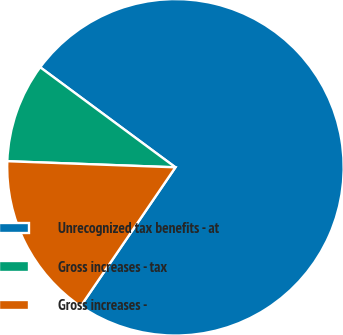Convert chart to OTSL. <chart><loc_0><loc_0><loc_500><loc_500><pie_chart><fcel>Unrecognized tax benefits - at<fcel>Gross increases - tax<fcel>Gross increases -<nl><fcel>74.39%<fcel>9.56%<fcel>16.05%<nl></chart> 